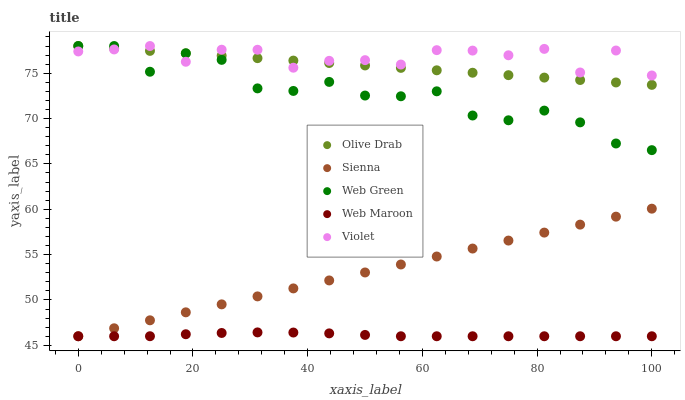Does Web Maroon have the minimum area under the curve?
Answer yes or no. Yes. Does Violet have the maximum area under the curve?
Answer yes or no. Yes. Does Web Green have the minimum area under the curve?
Answer yes or no. No. Does Web Green have the maximum area under the curve?
Answer yes or no. No. Is Olive Drab the smoothest?
Answer yes or no. Yes. Is Web Green the roughest?
Answer yes or no. Yes. Is Web Maroon the smoothest?
Answer yes or no. No. Is Web Maroon the roughest?
Answer yes or no. No. Does Sienna have the lowest value?
Answer yes or no. Yes. Does Web Green have the lowest value?
Answer yes or no. No. Does Violet have the highest value?
Answer yes or no. Yes. Does Web Maroon have the highest value?
Answer yes or no. No. Is Web Maroon less than Olive Drab?
Answer yes or no. Yes. Is Violet greater than Sienna?
Answer yes or no. Yes. Does Violet intersect Olive Drab?
Answer yes or no. Yes. Is Violet less than Olive Drab?
Answer yes or no. No. Is Violet greater than Olive Drab?
Answer yes or no. No. Does Web Maroon intersect Olive Drab?
Answer yes or no. No. 